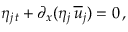Convert formula to latex. <formula><loc_0><loc_0><loc_500><loc_500>\eta _ { j \, t } + \partial _ { x } ( \eta _ { j } \, { \overline { u } } _ { j } ) = 0 \, ,</formula> 